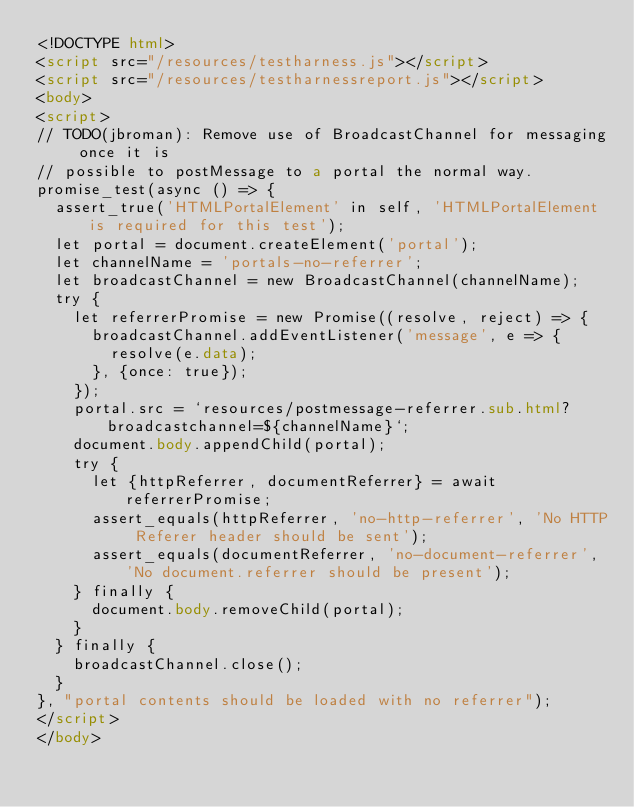Convert code to text. <code><loc_0><loc_0><loc_500><loc_500><_HTML_><!DOCTYPE html>
<script src="/resources/testharness.js"></script>
<script src="/resources/testharnessreport.js"></script>
<body>
<script>
// TODO(jbroman): Remove use of BroadcastChannel for messaging once it is
// possible to postMessage to a portal the normal way.
promise_test(async () => {
  assert_true('HTMLPortalElement' in self, 'HTMLPortalElement is required for this test');
  let portal = document.createElement('portal');
  let channelName = 'portals-no-referrer';
  let broadcastChannel = new BroadcastChannel(channelName);
  try {
    let referrerPromise = new Promise((resolve, reject) => {
      broadcastChannel.addEventListener('message', e => {
        resolve(e.data);
      }, {once: true});
    });
    portal.src = `resources/postmessage-referrer.sub.html?broadcastchannel=${channelName}`;
    document.body.appendChild(portal);
    try {
      let {httpReferrer, documentReferrer} = await referrerPromise;
      assert_equals(httpReferrer, 'no-http-referrer', 'No HTTP Referer header should be sent');
      assert_equals(documentReferrer, 'no-document-referrer', 'No document.referrer should be present');
    } finally {
      document.body.removeChild(portal);
    }
  } finally {
    broadcastChannel.close();
  }
}, "portal contents should be loaded with no referrer");
</script>
</body>
</code> 